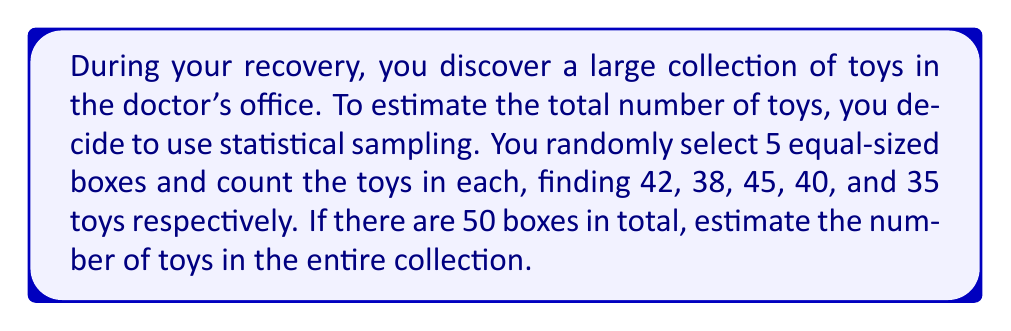Can you answer this question? Let's approach this step-by-step using statistical sampling methods:

1) First, calculate the mean number of toys per sampled box:
   $$\bar{x} = \frac{42 + 38 + 45 + 40 + 35}{5} = 40$$

2) The sample mean ($\bar{x} = 40$) is our best estimate of the average number of toys per box in the entire collection.

3) To estimate the total number of toys, we multiply this average by the total number of boxes:

   $$\text{Estimated total} = \bar{x} \times \text{Total boxes}$$
   $$\text{Estimated total} = 40 \times 50 = 2000$$

4) To assess the uncertainty in this estimate, we can calculate the standard error:

   a) First, calculate the sample variance:
      $$s^2 = \frac{\sum_{i=1}^{n} (x_i - \bar{x})^2}{n-1}$$
      $$s^2 = \frac{(42-40)^2 + (38-40)^2 + (45-40)^2 + (40-40)^2 + (35-40)^2}{5-1} = 15$$

   b) The standard error of the mean is:
      $$SE = \sqrt{\frac{s^2}{n}} = \sqrt{\frac{15}{5}} = \sqrt{3} \approx 1.73$$

   c) For the total estimate, we multiply this by the number of boxes:
      $$SE_{total} = 1.73 \times 50 \approx 86.6$$

5) We can express our estimate with its standard error:
   $$\text{Estimated total} = 2000 \pm 87 \text{ toys}$$

This means we're reasonably confident that the true number of toys is within about 87 of our 2000 estimate.
Answer: 2000 ± 87 toys 